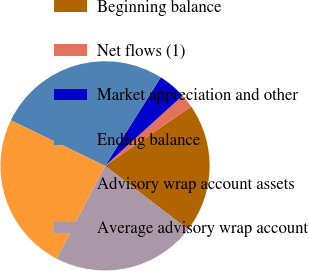Convert chart to OTSL. <chart><loc_0><loc_0><loc_500><loc_500><pie_chart><fcel>Beginning balance<fcel>Net flows (1)<fcel>Market appreciation and other<fcel>Ending balance<fcel>Advisory wrap account assets<fcel>Average advisory wrap account<nl><fcel>20.0%<fcel>2.1%<fcel>4.36%<fcel>26.77%<fcel>24.51%<fcel>22.26%<nl></chart> 